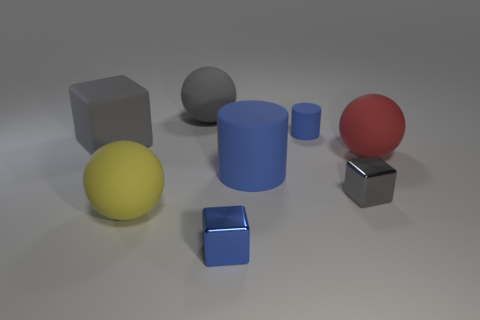How do the different shapes in the image relate to each other in size? The shapes in the image are arranged with size variation, where the yellow sphere and the red sphere are larger, conveying a sense of diversity and scale within the composition. What might the colors of the objects tell us about their possible material properties or purpose? The vibrant colors might suggest that the objects are designed for visual appeal or educational purposes, possibly to demonstrate color theory or to differentiate materials such as matte or glossy surfaces. 